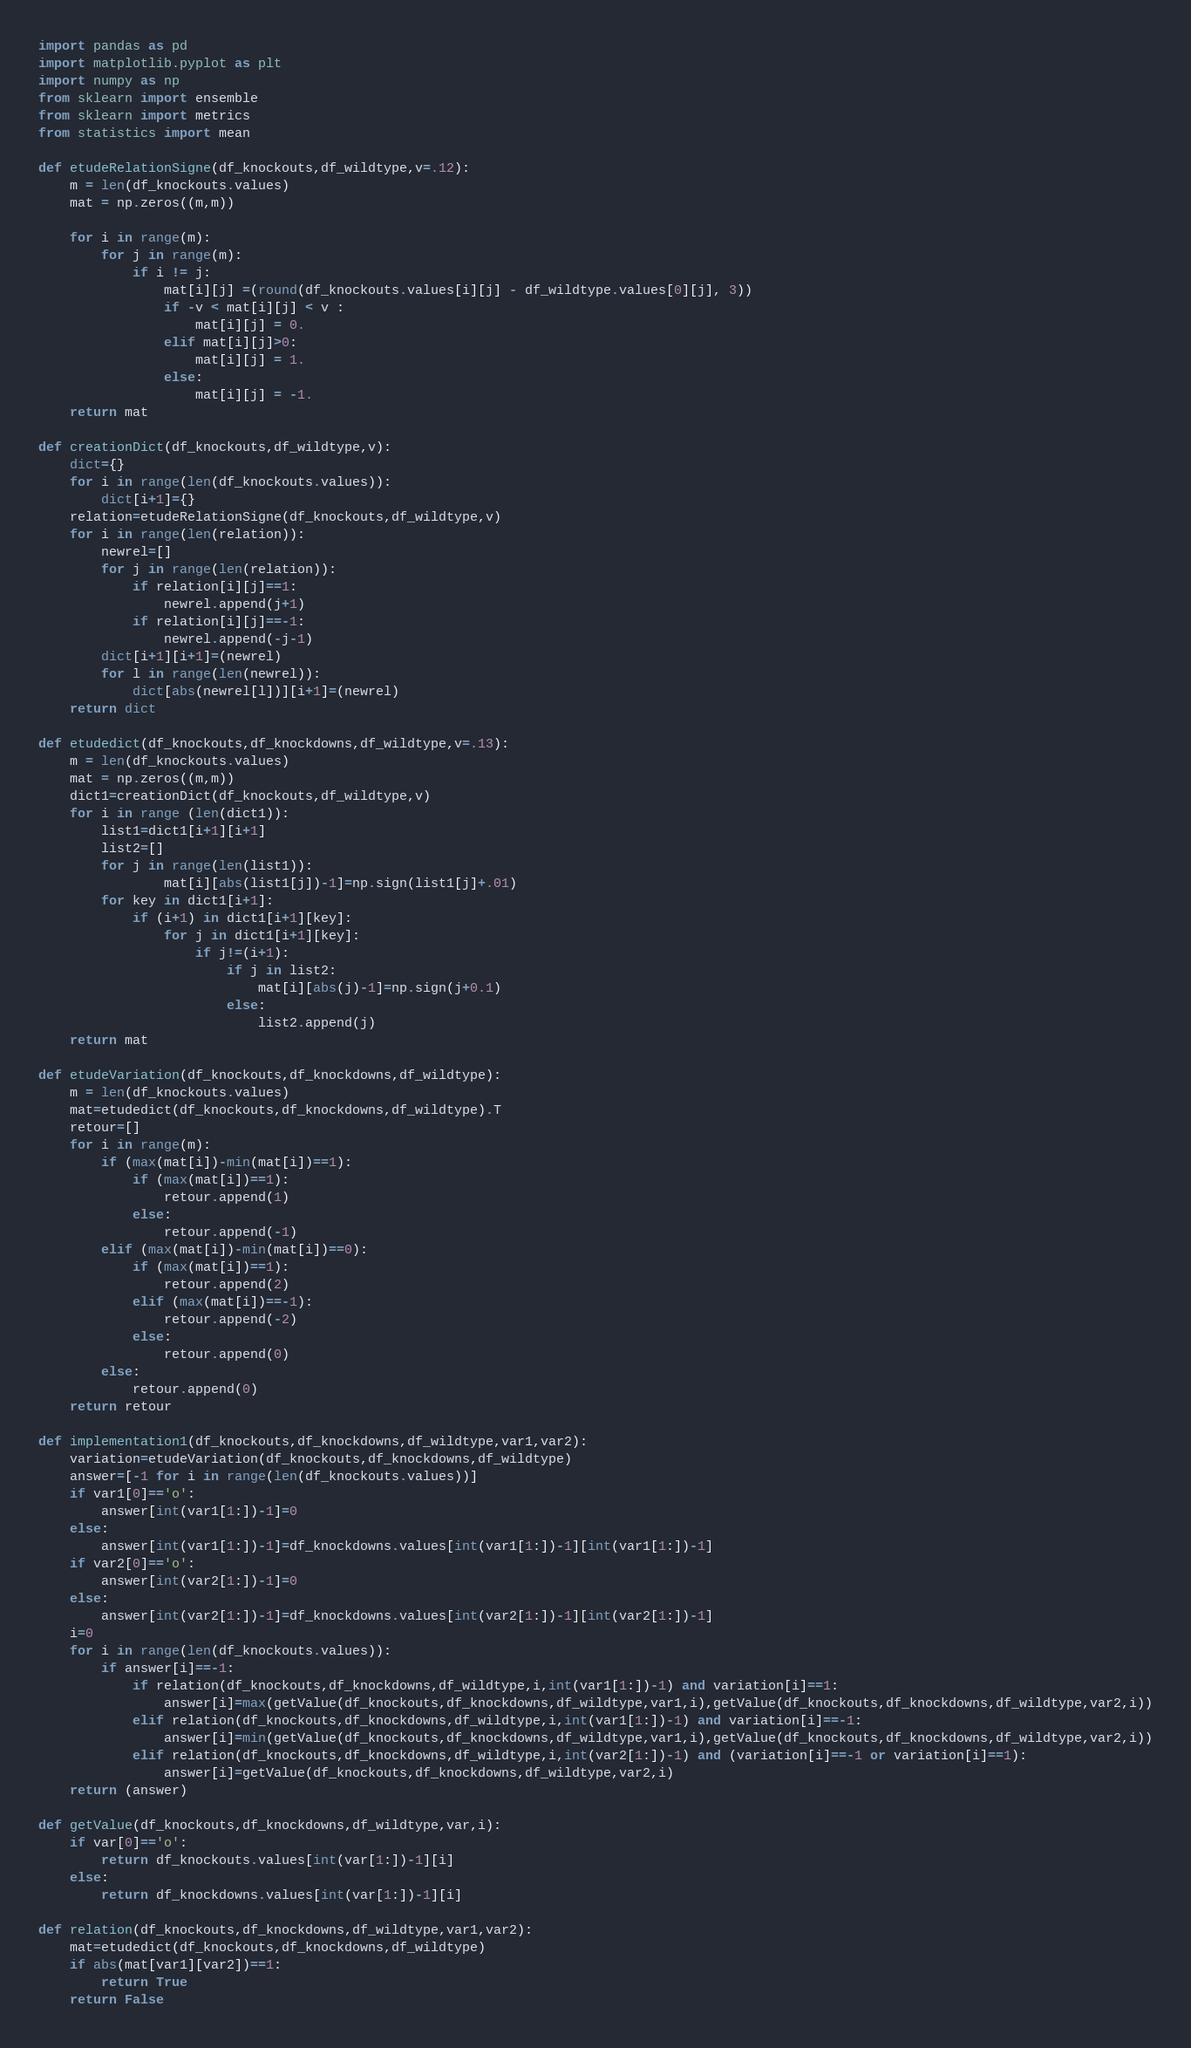<code> <loc_0><loc_0><loc_500><loc_500><_Python_>import pandas as pd
import matplotlib.pyplot as plt
import numpy as np
from sklearn import ensemble
from sklearn import metrics
from statistics import mean

def etudeRelationSigne(df_knockouts,df_wildtype,v=.12):
    m = len(df_knockouts.values)
    mat = np.zeros((m,m))

    for i in range(m):
        for j in range(m):
            if i != j:
                mat[i][j] =(round(df_knockouts.values[i][j] - df_wildtype.values[0][j], 3))
                if -v < mat[i][j] < v : 
                    mat[i][j] = 0.
                elif mat[i][j]>0:
                    mat[i][j] = 1.
                else:
                    mat[i][j] = -1.
    return mat

def creationDict(df_knockouts,df_wildtype,v):
    dict={}
    for i in range(len(df_knockouts.values)):
        dict[i+1]={}
    relation=etudeRelationSigne(df_knockouts,df_wildtype,v)  
    for i in range(len(relation)):
        newrel=[]
        for j in range(len(relation)):
            if relation[i][j]==1:
                newrel.append(j+1)
            if relation[i][j]==-1:
                newrel.append(-j-1)
        dict[i+1][i+1]=(newrel)
        for l in range(len(newrel)):
            dict[abs(newrel[l])][i+1]=(newrel)
    return dict

def etudedict(df_knockouts,df_knockdowns,df_wildtype,v=.13):
    m = len(df_knockouts.values)
    mat = np.zeros((m,m))
    dict1=creationDict(df_knockouts,df_wildtype,v)
    for i in range (len(dict1)):
        list1=dict1[i+1][i+1]
        list2=[]
        for j in range(len(list1)):
                mat[i][abs(list1[j])-1]=np.sign(list1[j]+.01)
        for key in dict1[i+1]:
            if (i+1) in dict1[i+1][key]:
                for j in dict1[i+1][key]:
                    if j!=(i+1):
                        if j in list2:
                            mat[i][abs(j)-1]=np.sign(j+0.1)
                        else:
                            list2.append(j)
    return mat

def etudeVariation(df_knockouts,df_knockdowns,df_wildtype):
    m = len(df_knockouts.values)
    mat=etudedict(df_knockouts,df_knockdowns,df_wildtype).T
    retour=[]
    for i in range(m):
        if (max(mat[i])-min(mat[i])==1):
            if (max(mat[i])==1):
                retour.append(1)
            else:
                retour.append(-1)
        elif (max(mat[i])-min(mat[i])==0):
            if (max(mat[i])==1):
                retour.append(2)
            elif (max(mat[i])==-1):
                retour.append(-2)
            else:
                retour.append(0)
        else:
            retour.append(0)
    return retour

def implementation1(df_knockouts,df_knockdowns,df_wildtype,var1,var2):
    variation=etudeVariation(df_knockouts,df_knockdowns,df_wildtype)
    answer=[-1 for i in range(len(df_knockouts.values))]
    if var1[0]=='o':
        answer[int(var1[1:])-1]=0
    else:
        answer[int(var1[1:])-1]=df_knockdowns.values[int(var1[1:])-1][int(var1[1:])-1]
    if var2[0]=='o':
        answer[int(var2[1:])-1]=0
    else:
        answer[int(var2[1:])-1]=df_knockdowns.values[int(var2[1:])-1][int(var2[1:])-1]
    i=0
    for i in range(len(df_knockouts.values)):
        if answer[i]==-1:
            if relation(df_knockouts,df_knockdowns,df_wildtype,i,int(var1[1:])-1) and variation[i]==1:
                answer[i]=max(getValue(df_knockouts,df_knockdowns,df_wildtype,var1,i),getValue(df_knockouts,df_knockdowns,df_wildtype,var2,i))
            elif relation(df_knockouts,df_knockdowns,df_wildtype,i,int(var1[1:])-1) and variation[i]==-1:
                answer[i]=min(getValue(df_knockouts,df_knockdowns,df_wildtype,var1,i),getValue(df_knockouts,df_knockdowns,df_wildtype,var2,i))
            elif relation(df_knockouts,df_knockdowns,df_wildtype,i,int(var2[1:])-1) and (variation[i]==-1 or variation[i]==1):
                answer[i]=getValue(df_knockouts,df_knockdowns,df_wildtype,var2,i)
    return (answer)

def getValue(df_knockouts,df_knockdowns,df_wildtype,var,i):
    if var[0]=='o':
        return df_knockouts.values[int(var[1:])-1][i]
    else:
        return df_knockdowns.values[int(var[1:])-1][i]
    
def relation(df_knockouts,df_knockdowns,df_wildtype,var1,var2):
    mat=etudedict(df_knockouts,df_knockdowns,df_wildtype)
    if abs(mat[var1][var2])==1:
        return True
    return False
</code> 